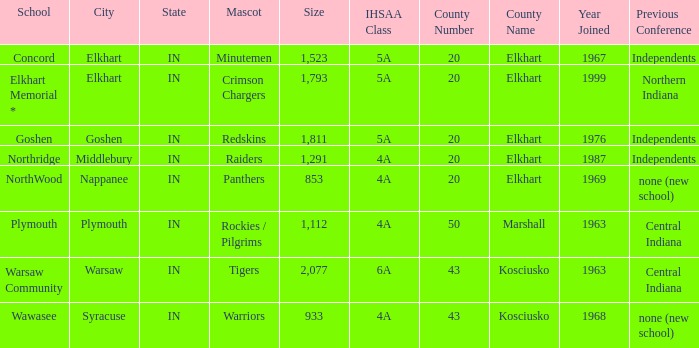What is the size of the team that was previously from Central Indiana conference, and is in IHSSA Class 4a? 1112.0. 